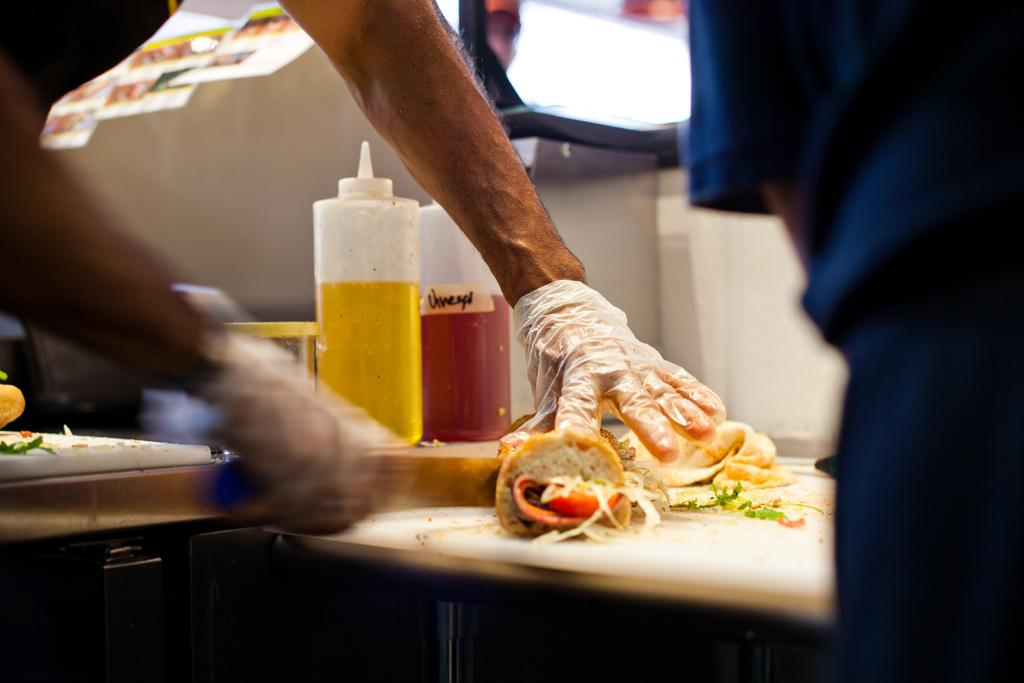Who is present in the image? There is a person in the image. What is the person wearing on their hands? The person is wearing hand gloves. What is the person holding in their hand? The person is holding an object in their hand. What can be seen on the table in the image? There are bottles, food items, and other objects on the table in the image. What type of quilt is being used to cover the person in the image? There is no quilt present in the image; the person is not covered by any fabric. 